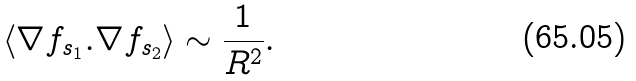<formula> <loc_0><loc_0><loc_500><loc_500>\langle \nabla f _ { s _ { 1 } } . \nabla f _ { s _ { 2 } } \rangle \sim \frac { 1 } { R ^ { 2 } } .</formula> 